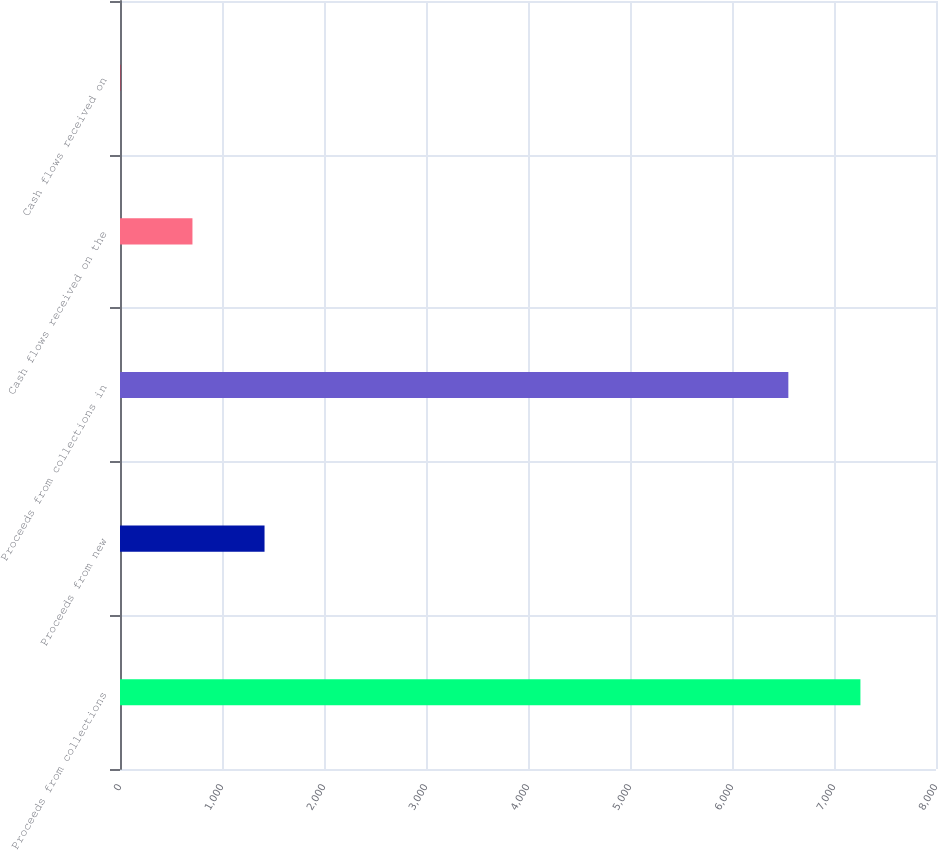Convert chart. <chart><loc_0><loc_0><loc_500><loc_500><bar_chart><fcel>Proceeds from collections<fcel>Proceeds from new<fcel>Proceeds from collections in<fcel>Cash flows received on the<fcel>Cash flows received on<nl><fcel>7259.06<fcel>1417.02<fcel>6552.4<fcel>710.36<fcel>3.7<nl></chart> 